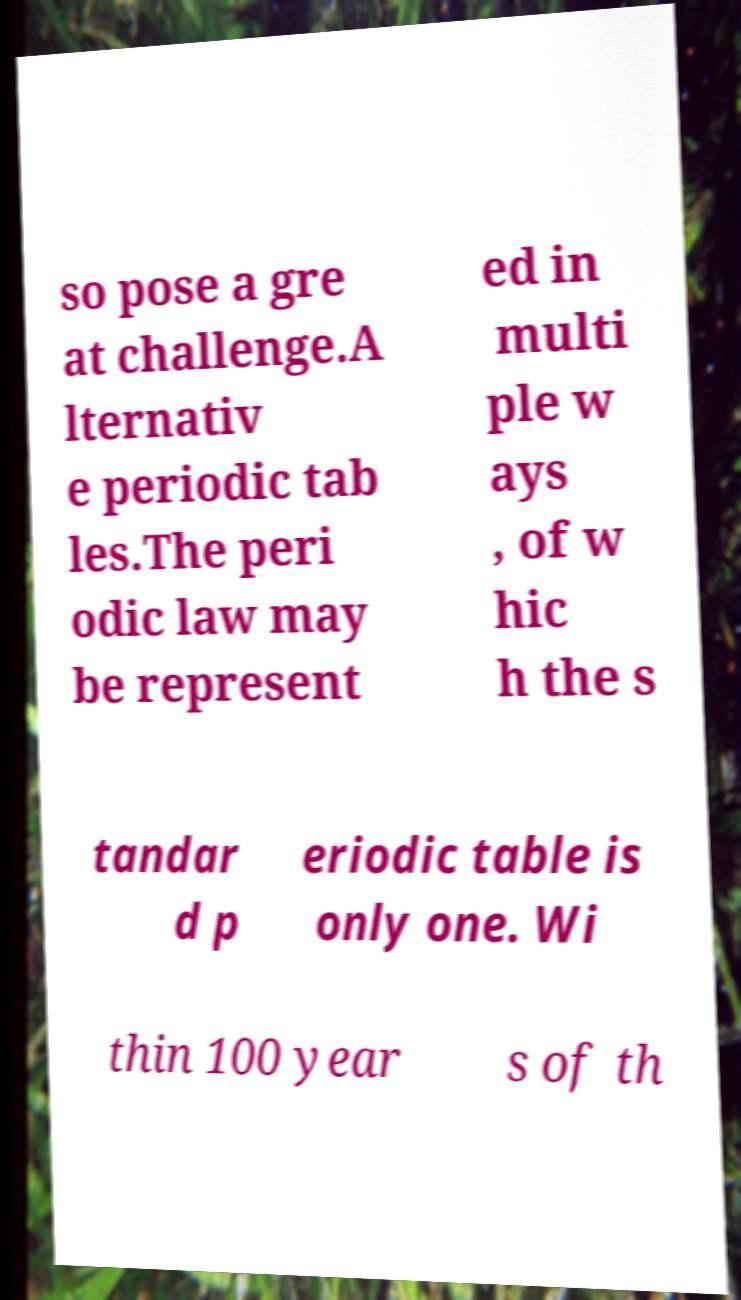Can you accurately transcribe the text from the provided image for me? so pose a gre at challenge.A lternativ e periodic tab les.The peri odic law may be represent ed in multi ple w ays , of w hic h the s tandar d p eriodic table is only one. Wi thin 100 year s of th 